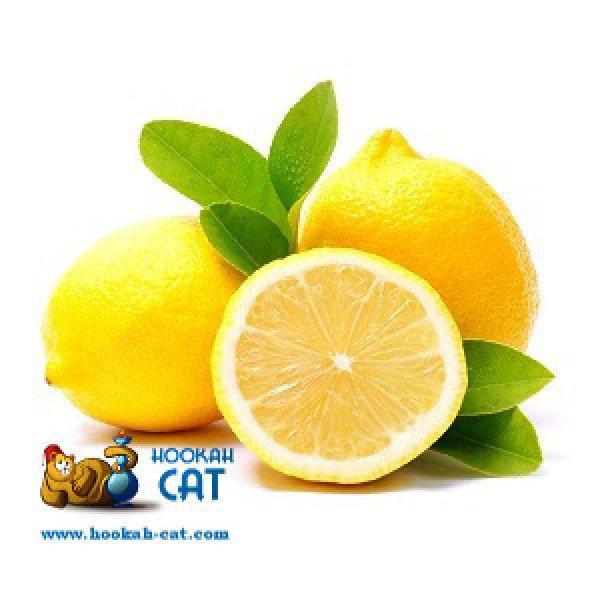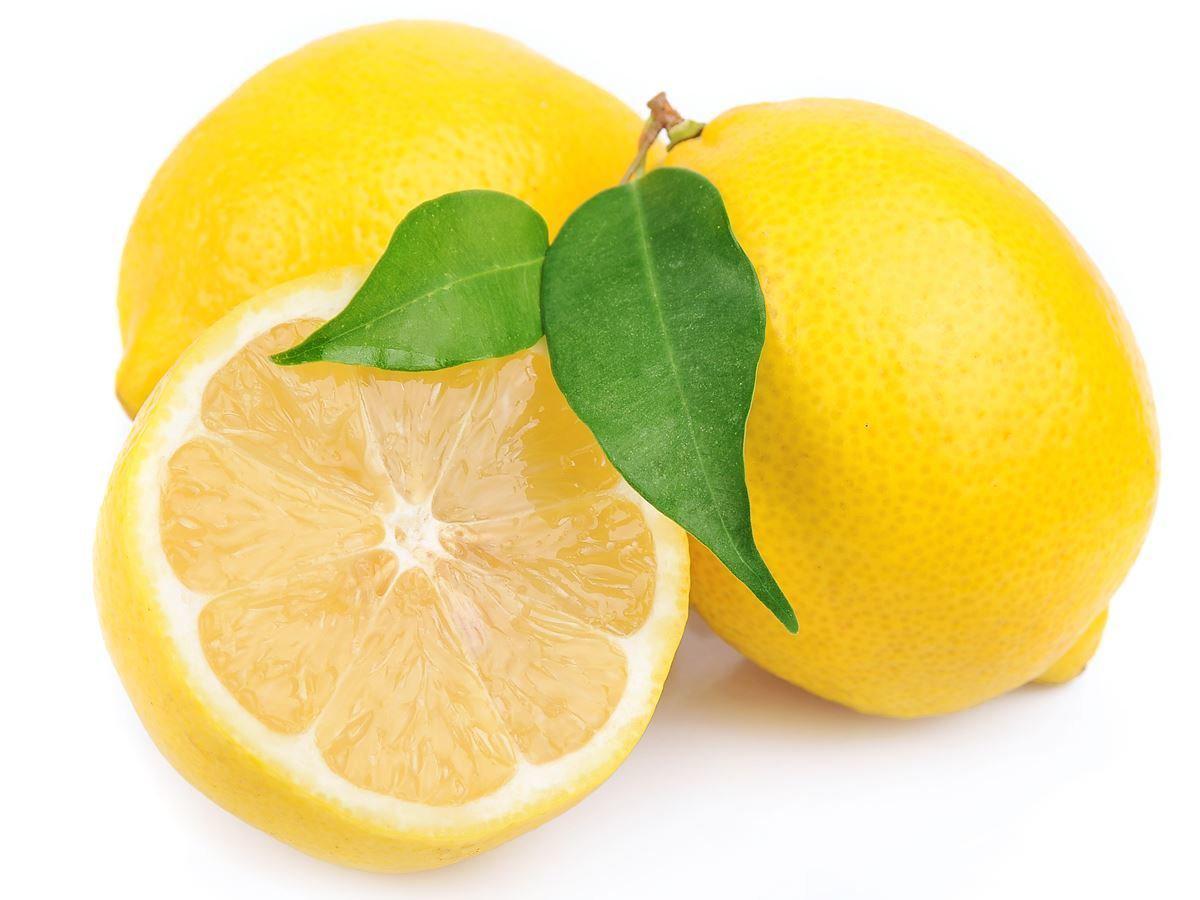The first image is the image on the left, the second image is the image on the right. Considering the images on both sides, is "No leaves are visible in the pictures on the right." valid? Answer yes or no. No. 